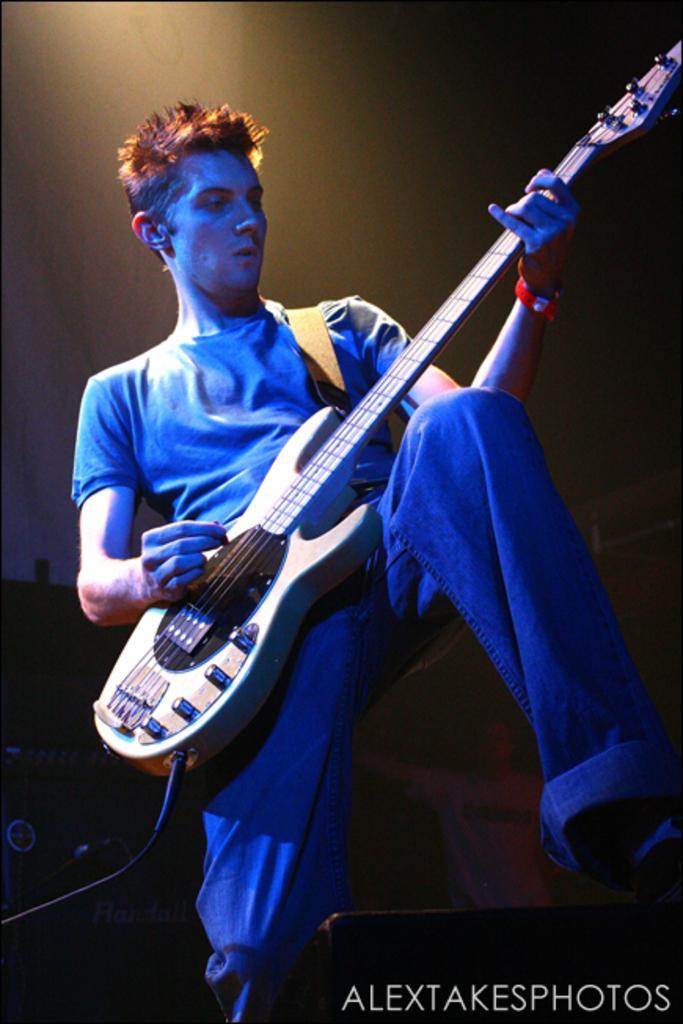Could you give a brief overview of what you see in this image? Person playing guitar. 